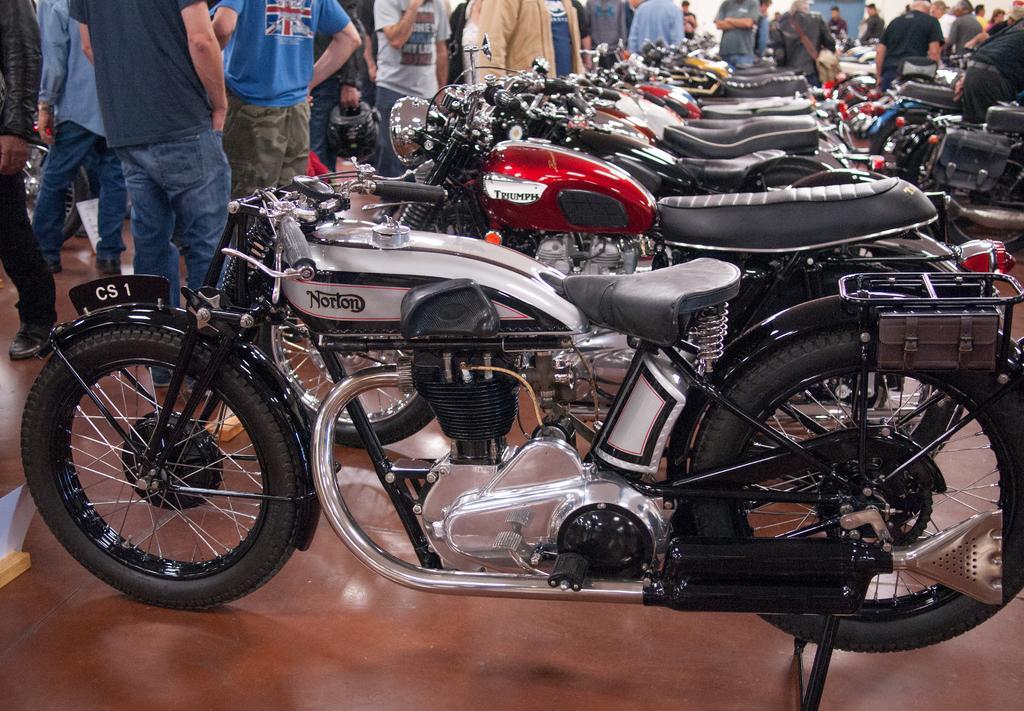Can you describe this image briefly? This image is taken indoors. At the bottom of the image there is a floor. In the middle of the image many bikes are parked on the floor. In the background many people are standing on the floor and a few are walking. 